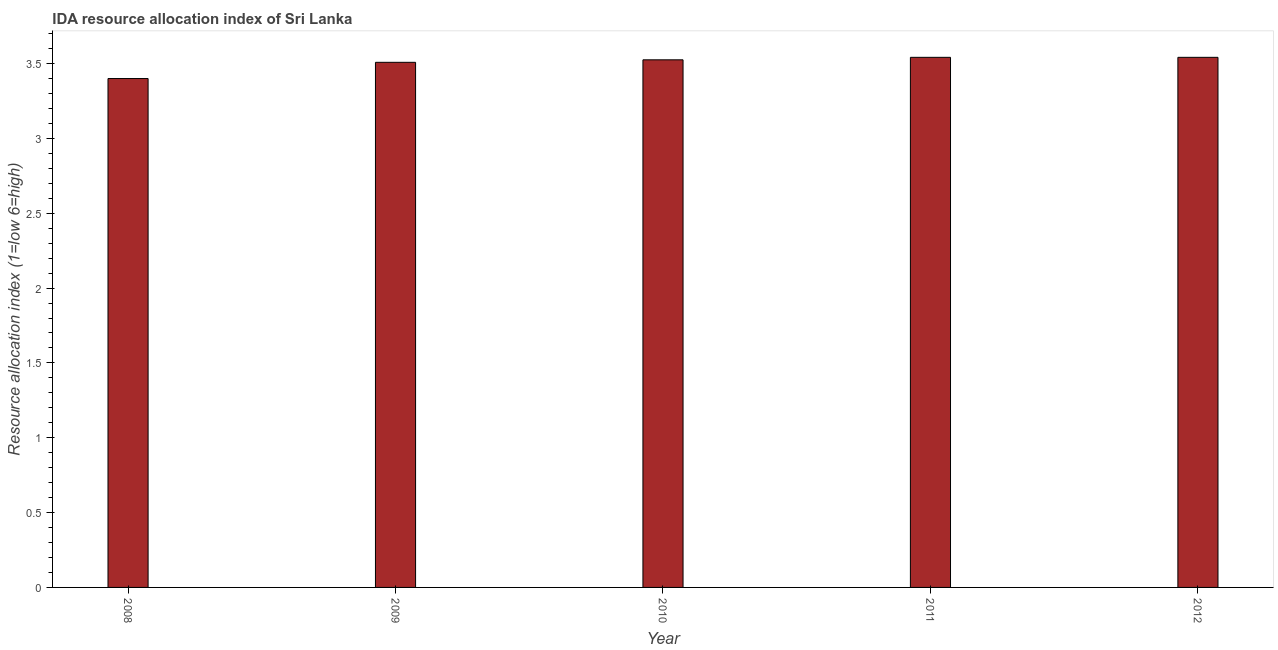Does the graph contain grids?
Keep it short and to the point. No. What is the title of the graph?
Offer a terse response. IDA resource allocation index of Sri Lanka. What is the label or title of the X-axis?
Offer a very short reply. Year. What is the label or title of the Y-axis?
Offer a terse response. Resource allocation index (1=low 6=high). What is the ida resource allocation index in 2012?
Your answer should be very brief. 3.54. Across all years, what is the maximum ida resource allocation index?
Offer a terse response. 3.54. Across all years, what is the minimum ida resource allocation index?
Offer a very short reply. 3.4. In which year was the ida resource allocation index minimum?
Provide a succinct answer. 2008. What is the sum of the ida resource allocation index?
Offer a very short reply. 17.52. What is the difference between the ida resource allocation index in 2009 and 2012?
Provide a succinct answer. -0.03. What is the average ida resource allocation index per year?
Provide a short and direct response. 3.5. What is the median ida resource allocation index?
Make the answer very short. 3.52. In how many years, is the ida resource allocation index greater than 0.1 ?
Your answer should be compact. 5. Do a majority of the years between 2010 and 2012 (inclusive) have ida resource allocation index greater than 1 ?
Your answer should be compact. Yes. Is the sum of the ida resource allocation index in 2010 and 2012 greater than the maximum ida resource allocation index across all years?
Give a very brief answer. Yes. What is the difference between the highest and the lowest ida resource allocation index?
Your response must be concise. 0.14. In how many years, is the ida resource allocation index greater than the average ida resource allocation index taken over all years?
Offer a very short reply. 4. How many years are there in the graph?
Provide a succinct answer. 5. What is the difference between two consecutive major ticks on the Y-axis?
Your answer should be compact. 0.5. What is the Resource allocation index (1=low 6=high) of 2008?
Your answer should be compact. 3.4. What is the Resource allocation index (1=low 6=high) in 2009?
Keep it short and to the point. 3.51. What is the Resource allocation index (1=low 6=high) of 2010?
Keep it short and to the point. 3.52. What is the Resource allocation index (1=low 6=high) in 2011?
Keep it short and to the point. 3.54. What is the Resource allocation index (1=low 6=high) of 2012?
Your answer should be compact. 3.54. What is the difference between the Resource allocation index (1=low 6=high) in 2008 and 2009?
Your answer should be very brief. -0.11. What is the difference between the Resource allocation index (1=low 6=high) in 2008 and 2010?
Provide a short and direct response. -0.12. What is the difference between the Resource allocation index (1=low 6=high) in 2008 and 2011?
Provide a short and direct response. -0.14. What is the difference between the Resource allocation index (1=low 6=high) in 2008 and 2012?
Offer a terse response. -0.14. What is the difference between the Resource allocation index (1=low 6=high) in 2009 and 2010?
Provide a short and direct response. -0.02. What is the difference between the Resource allocation index (1=low 6=high) in 2009 and 2011?
Offer a very short reply. -0.03. What is the difference between the Resource allocation index (1=low 6=high) in 2009 and 2012?
Make the answer very short. -0.03. What is the difference between the Resource allocation index (1=low 6=high) in 2010 and 2011?
Ensure brevity in your answer.  -0.02. What is the difference between the Resource allocation index (1=low 6=high) in 2010 and 2012?
Offer a very short reply. -0.02. What is the ratio of the Resource allocation index (1=low 6=high) in 2008 to that in 2010?
Keep it short and to the point. 0.96. What is the ratio of the Resource allocation index (1=low 6=high) in 2008 to that in 2011?
Your answer should be compact. 0.96. What is the ratio of the Resource allocation index (1=low 6=high) in 2008 to that in 2012?
Keep it short and to the point. 0.96. What is the ratio of the Resource allocation index (1=low 6=high) in 2009 to that in 2011?
Your answer should be compact. 0.99. What is the ratio of the Resource allocation index (1=low 6=high) in 2009 to that in 2012?
Give a very brief answer. 0.99. 